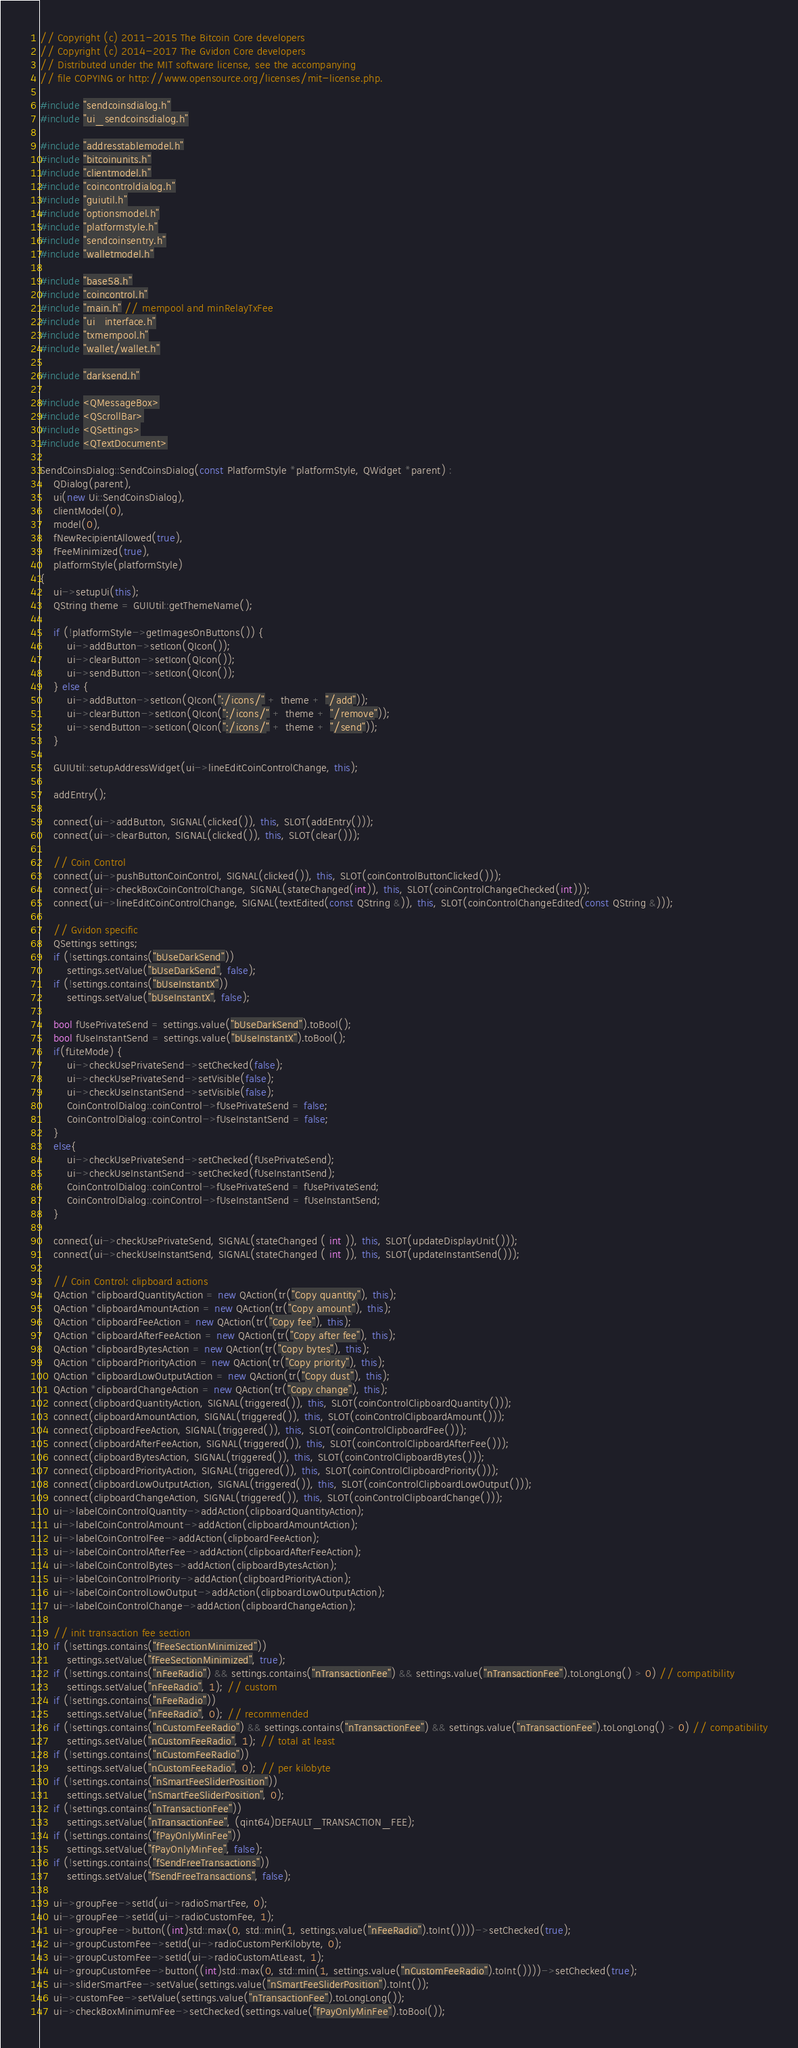Convert code to text. <code><loc_0><loc_0><loc_500><loc_500><_C++_>// Copyright (c) 2011-2015 The Bitcoin Core developers
// Copyright (c) 2014-2017 The Gvidon Core developers
// Distributed under the MIT software license, see the accompanying
// file COPYING or http://www.opensource.org/licenses/mit-license.php.

#include "sendcoinsdialog.h"
#include "ui_sendcoinsdialog.h"

#include "addresstablemodel.h"
#include "bitcoinunits.h"
#include "clientmodel.h"
#include "coincontroldialog.h"
#include "guiutil.h"
#include "optionsmodel.h"
#include "platformstyle.h"
#include "sendcoinsentry.h"
#include "walletmodel.h"

#include "base58.h"
#include "coincontrol.h"
#include "main.h" // mempool and minRelayTxFee
#include "ui_interface.h"
#include "txmempool.h"
#include "wallet/wallet.h"

#include "darksend.h"

#include <QMessageBox>
#include <QScrollBar>
#include <QSettings>
#include <QTextDocument>

SendCoinsDialog::SendCoinsDialog(const PlatformStyle *platformStyle, QWidget *parent) :
    QDialog(parent),
    ui(new Ui::SendCoinsDialog),
    clientModel(0),
    model(0),
    fNewRecipientAllowed(true),
    fFeeMinimized(true),
    platformStyle(platformStyle)
{
    ui->setupUi(this);
    QString theme = GUIUtil::getThemeName();

    if (!platformStyle->getImagesOnButtons()) {
        ui->addButton->setIcon(QIcon());
        ui->clearButton->setIcon(QIcon());
        ui->sendButton->setIcon(QIcon());
    } else {
        ui->addButton->setIcon(QIcon(":/icons/" + theme + "/add"));
        ui->clearButton->setIcon(QIcon(":/icons/" + theme + "/remove"));
        ui->sendButton->setIcon(QIcon(":/icons/" + theme + "/send"));
    }

    GUIUtil::setupAddressWidget(ui->lineEditCoinControlChange, this);

    addEntry();

    connect(ui->addButton, SIGNAL(clicked()), this, SLOT(addEntry()));
    connect(ui->clearButton, SIGNAL(clicked()), this, SLOT(clear()));

    // Coin Control
    connect(ui->pushButtonCoinControl, SIGNAL(clicked()), this, SLOT(coinControlButtonClicked()));
    connect(ui->checkBoxCoinControlChange, SIGNAL(stateChanged(int)), this, SLOT(coinControlChangeChecked(int)));
    connect(ui->lineEditCoinControlChange, SIGNAL(textEdited(const QString &)), this, SLOT(coinControlChangeEdited(const QString &)));

    // Gvidon specific
    QSettings settings;
    if (!settings.contains("bUseDarkSend"))
        settings.setValue("bUseDarkSend", false);
    if (!settings.contains("bUseInstantX"))
        settings.setValue("bUseInstantX", false);

    bool fUsePrivateSend = settings.value("bUseDarkSend").toBool();
    bool fUseInstantSend = settings.value("bUseInstantX").toBool();
    if(fLiteMode) {
        ui->checkUsePrivateSend->setChecked(false);
        ui->checkUsePrivateSend->setVisible(false);
        ui->checkUseInstantSend->setVisible(false);
        CoinControlDialog::coinControl->fUsePrivateSend = false;
        CoinControlDialog::coinControl->fUseInstantSend = false;
    }
    else{
        ui->checkUsePrivateSend->setChecked(fUsePrivateSend);
        ui->checkUseInstantSend->setChecked(fUseInstantSend);
        CoinControlDialog::coinControl->fUsePrivateSend = fUsePrivateSend;
        CoinControlDialog::coinControl->fUseInstantSend = fUseInstantSend;
    }

    connect(ui->checkUsePrivateSend, SIGNAL(stateChanged ( int )), this, SLOT(updateDisplayUnit()));
    connect(ui->checkUseInstantSend, SIGNAL(stateChanged ( int )), this, SLOT(updateInstantSend()));

    // Coin Control: clipboard actions
    QAction *clipboardQuantityAction = new QAction(tr("Copy quantity"), this);
    QAction *clipboardAmountAction = new QAction(tr("Copy amount"), this);
    QAction *clipboardFeeAction = new QAction(tr("Copy fee"), this);
    QAction *clipboardAfterFeeAction = new QAction(tr("Copy after fee"), this);
    QAction *clipboardBytesAction = new QAction(tr("Copy bytes"), this);
    QAction *clipboardPriorityAction = new QAction(tr("Copy priority"), this);
    QAction *clipboardLowOutputAction = new QAction(tr("Copy dust"), this);
    QAction *clipboardChangeAction = new QAction(tr("Copy change"), this);
    connect(clipboardQuantityAction, SIGNAL(triggered()), this, SLOT(coinControlClipboardQuantity()));
    connect(clipboardAmountAction, SIGNAL(triggered()), this, SLOT(coinControlClipboardAmount()));
    connect(clipboardFeeAction, SIGNAL(triggered()), this, SLOT(coinControlClipboardFee()));
    connect(clipboardAfterFeeAction, SIGNAL(triggered()), this, SLOT(coinControlClipboardAfterFee()));
    connect(clipboardBytesAction, SIGNAL(triggered()), this, SLOT(coinControlClipboardBytes()));
    connect(clipboardPriorityAction, SIGNAL(triggered()), this, SLOT(coinControlClipboardPriority()));
    connect(clipboardLowOutputAction, SIGNAL(triggered()), this, SLOT(coinControlClipboardLowOutput()));
    connect(clipboardChangeAction, SIGNAL(triggered()), this, SLOT(coinControlClipboardChange()));
    ui->labelCoinControlQuantity->addAction(clipboardQuantityAction);
    ui->labelCoinControlAmount->addAction(clipboardAmountAction);
    ui->labelCoinControlFee->addAction(clipboardFeeAction);
    ui->labelCoinControlAfterFee->addAction(clipboardAfterFeeAction);
    ui->labelCoinControlBytes->addAction(clipboardBytesAction);
    ui->labelCoinControlPriority->addAction(clipboardPriorityAction);
    ui->labelCoinControlLowOutput->addAction(clipboardLowOutputAction);
    ui->labelCoinControlChange->addAction(clipboardChangeAction);

    // init transaction fee section
    if (!settings.contains("fFeeSectionMinimized"))
        settings.setValue("fFeeSectionMinimized", true);
    if (!settings.contains("nFeeRadio") && settings.contains("nTransactionFee") && settings.value("nTransactionFee").toLongLong() > 0) // compatibility
        settings.setValue("nFeeRadio", 1); // custom
    if (!settings.contains("nFeeRadio"))
        settings.setValue("nFeeRadio", 0); // recommended
    if (!settings.contains("nCustomFeeRadio") && settings.contains("nTransactionFee") && settings.value("nTransactionFee").toLongLong() > 0) // compatibility
        settings.setValue("nCustomFeeRadio", 1); // total at least
    if (!settings.contains("nCustomFeeRadio"))
        settings.setValue("nCustomFeeRadio", 0); // per kilobyte
    if (!settings.contains("nSmartFeeSliderPosition"))
        settings.setValue("nSmartFeeSliderPosition", 0);
    if (!settings.contains("nTransactionFee"))
        settings.setValue("nTransactionFee", (qint64)DEFAULT_TRANSACTION_FEE);
    if (!settings.contains("fPayOnlyMinFee"))
        settings.setValue("fPayOnlyMinFee", false);
    if (!settings.contains("fSendFreeTransactions"))
        settings.setValue("fSendFreeTransactions", false);

    ui->groupFee->setId(ui->radioSmartFee, 0);
    ui->groupFee->setId(ui->radioCustomFee, 1);
    ui->groupFee->button((int)std::max(0, std::min(1, settings.value("nFeeRadio").toInt())))->setChecked(true);
    ui->groupCustomFee->setId(ui->radioCustomPerKilobyte, 0);
    ui->groupCustomFee->setId(ui->radioCustomAtLeast, 1);
    ui->groupCustomFee->button((int)std::max(0, std::min(1, settings.value("nCustomFeeRadio").toInt())))->setChecked(true);
    ui->sliderSmartFee->setValue(settings.value("nSmartFeeSliderPosition").toInt());
    ui->customFee->setValue(settings.value("nTransactionFee").toLongLong());
    ui->checkBoxMinimumFee->setChecked(settings.value("fPayOnlyMinFee").toBool());</code> 